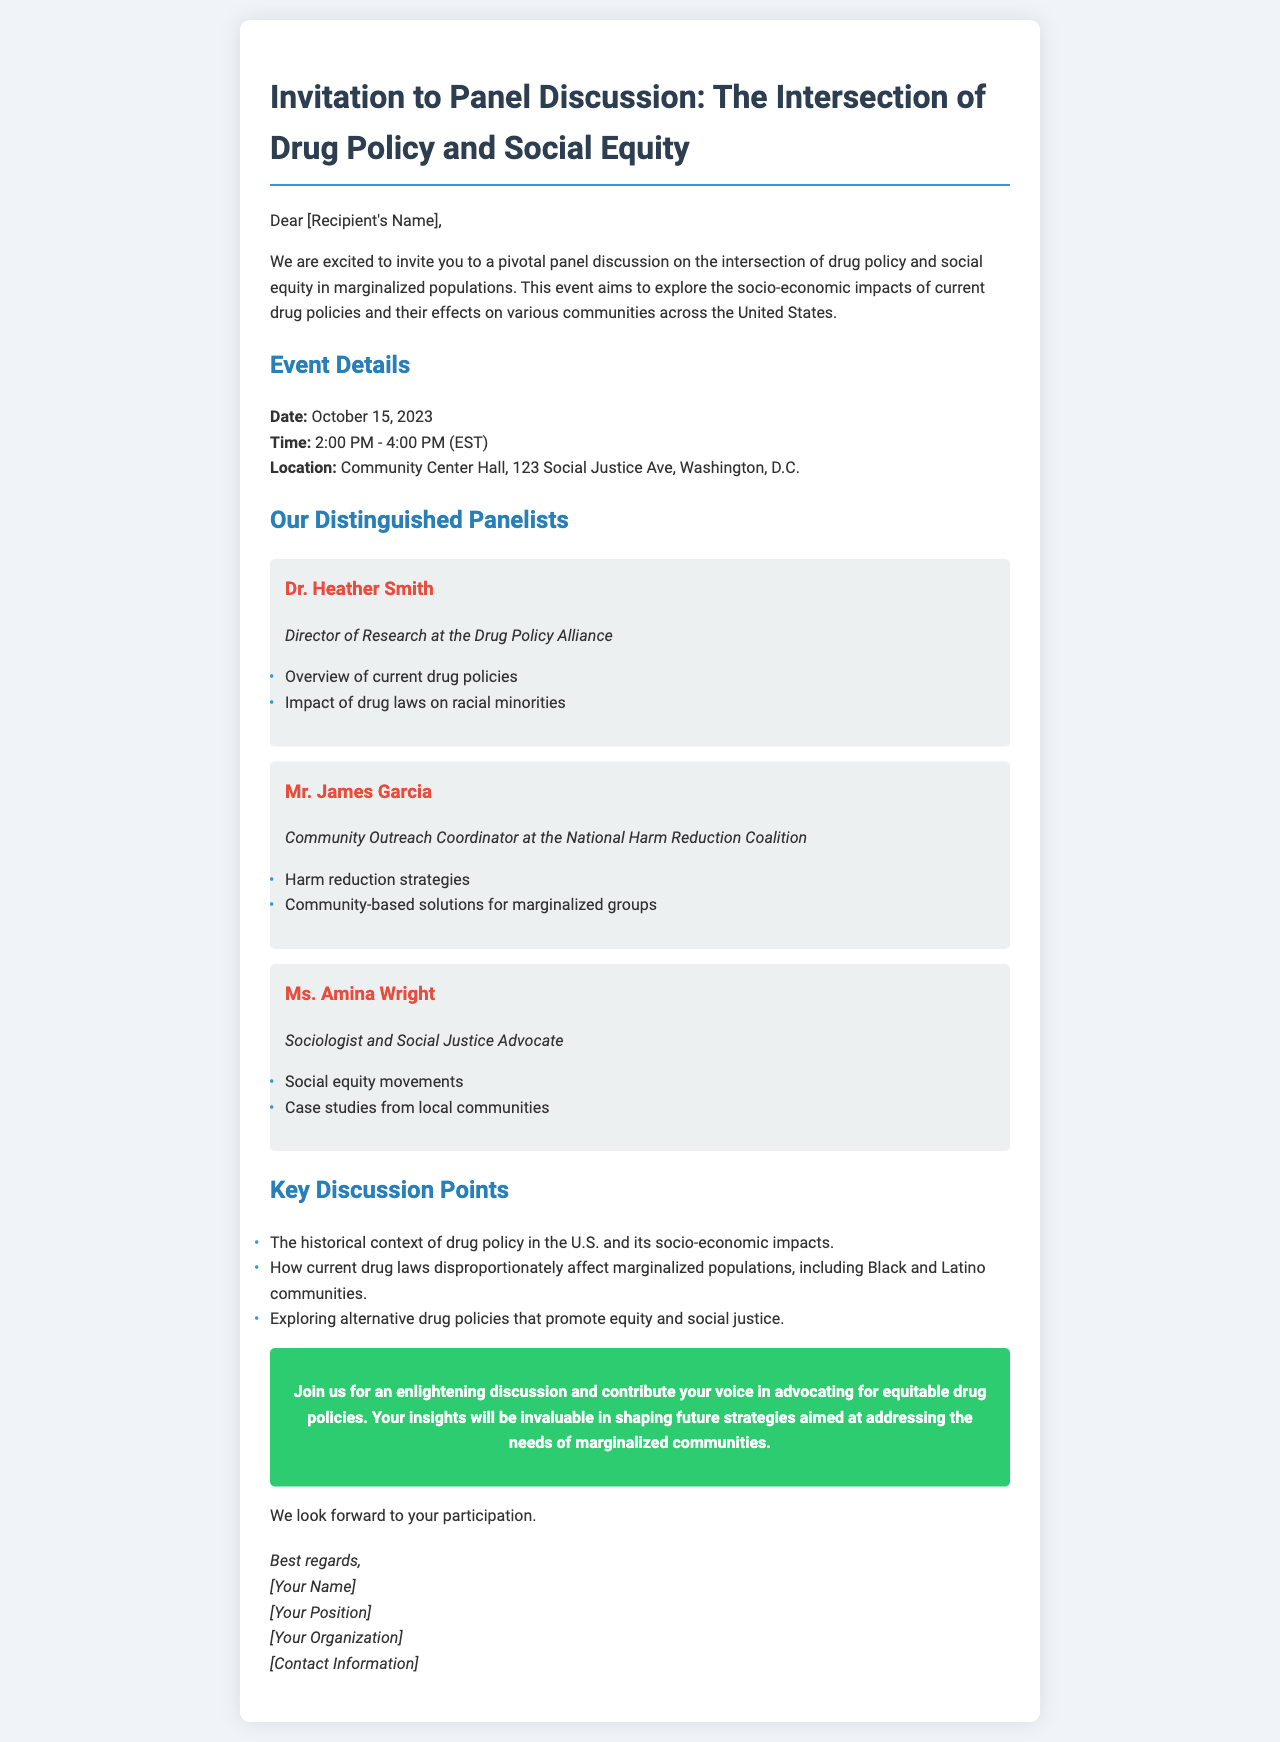What is the date of the panel discussion? The date of the panel discussion is explicitly mentioned in the event details section of the document.
Answer: October 15, 2023 What time does the panel discussion begin? The start time is listed in the event details section as part of the scheduled times for the discussion.
Answer: 2:00 PM Who is the Director of Research at the Drug Policy Alliance? The name of the panelist holding this title is provided in the section about distinguished panelists.
Answer: Dr. Heather Smith What organization is Mr. James Garcia associated with? The document specifies the organization in the description of the panelist's role.
Answer: National Harm Reduction Coalition What is one of the key discussion points regarding drug laws? The document summarizes key discussion points, including the impact on marginalized populations.
Answer: Disproportionately affect marginalized populations How many panelists are discussed in the document? The number of distinguished panelists can be counted from the panelist section in the document.
Answer: Three What type of strategies will Mr. James Garcia discuss? The document outlines the topics that Mr. Garcia will address, providing clarity on his focus area.
Answer: Harm reduction strategies What is the location of the event? The location is provided in the event details section of the document.
Answer: Community Center Hall, 123 Social Justice Ave, Washington, D.C What organization is the host of the event? The host is implied through the contact information section, although it is not explicitly mentioned in the invitation text.
Answer: [Your Organization] 